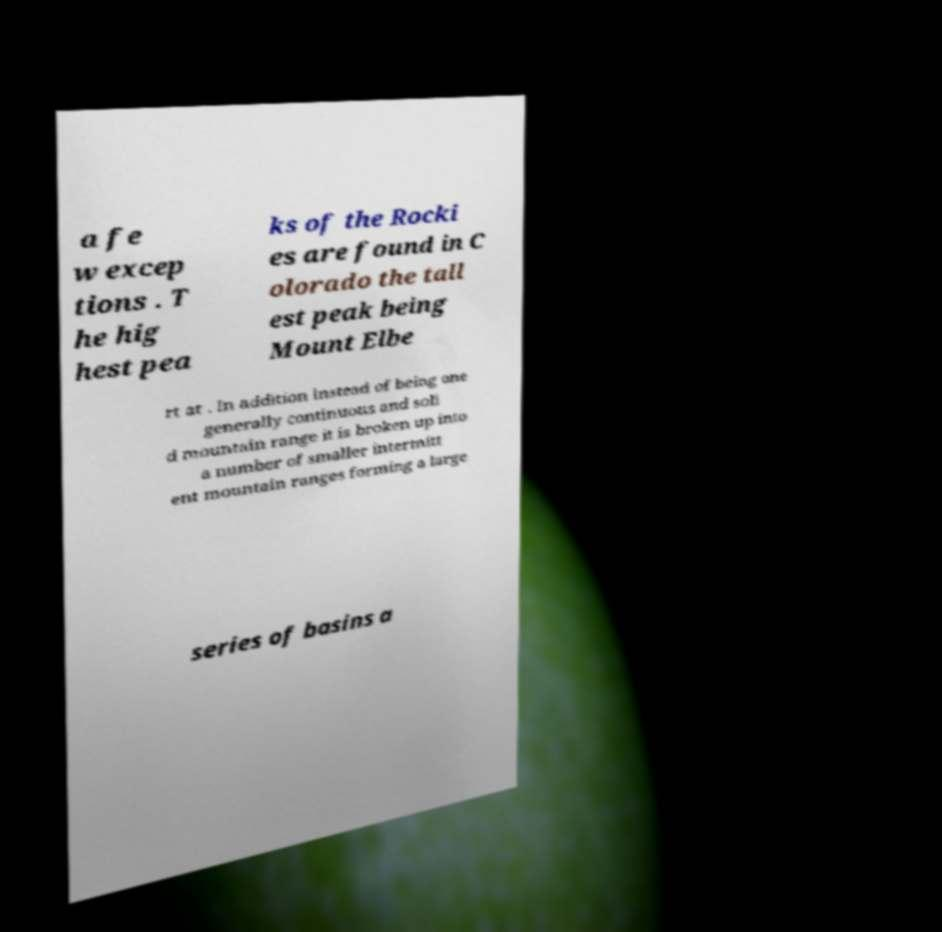Please read and relay the text visible in this image. What does it say? a fe w excep tions . T he hig hest pea ks of the Rocki es are found in C olorado the tall est peak being Mount Elbe rt at . In addition instead of being one generally continuous and soli d mountain range it is broken up into a number of smaller intermitt ent mountain ranges forming a large series of basins a 